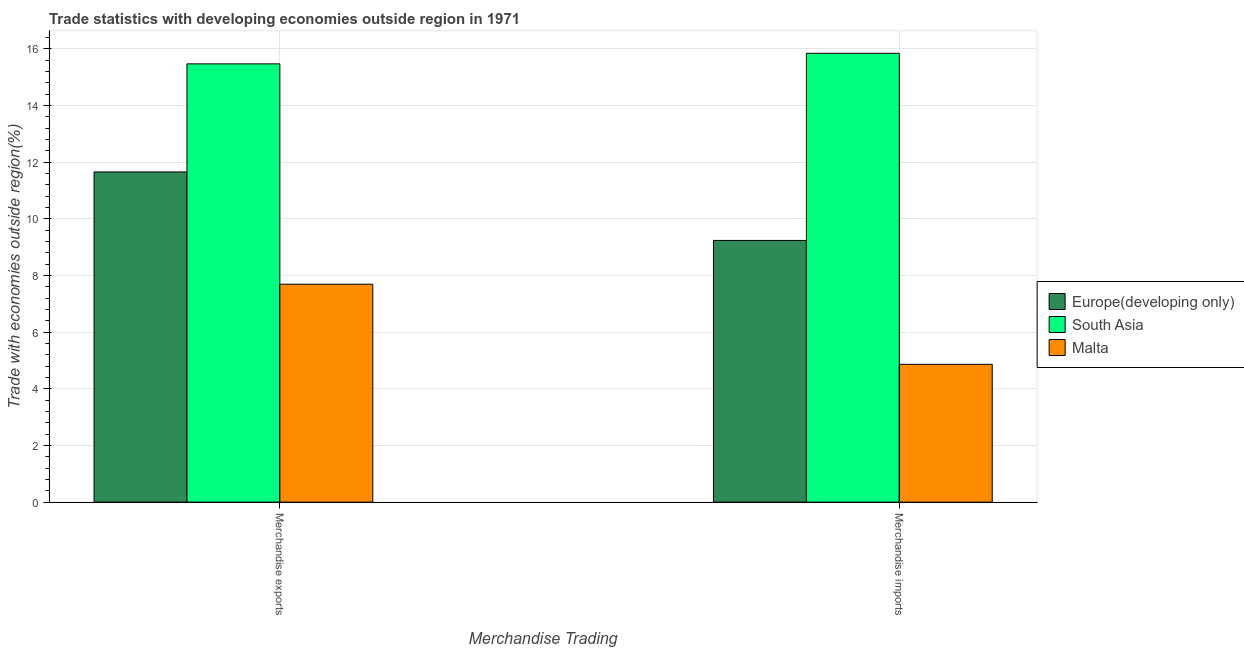How many groups of bars are there?
Your answer should be compact. 2. Are the number of bars per tick equal to the number of legend labels?
Give a very brief answer. Yes. Are the number of bars on each tick of the X-axis equal?
Make the answer very short. Yes. How many bars are there on the 2nd tick from the right?
Your response must be concise. 3. What is the label of the 1st group of bars from the left?
Your response must be concise. Merchandise exports. What is the merchandise exports in Malta?
Your answer should be very brief. 7.69. Across all countries, what is the maximum merchandise exports?
Provide a succinct answer. 15.47. Across all countries, what is the minimum merchandise imports?
Your response must be concise. 4.86. In which country was the merchandise imports minimum?
Ensure brevity in your answer.  Malta. What is the total merchandise exports in the graph?
Ensure brevity in your answer.  34.82. What is the difference between the merchandise imports in Europe(developing only) and that in South Asia?
Ensure brevity in your answer.  -6.61. What is the difference between the merchandise imports in Malta and the merchandise exports in Europe(developing only)?
Offer a very short reply. -6.79. What is the average merchandise imports per country?
Your response must be concise. 9.98. What is the difference between the merchandise imports and merchandise exports in South Asia?
Your response must be concise. 0.37. What is the ratio of the merchandise exports in South Asia to that in Europe(developing only)?
Your answer should be compact. 1.33. In how many countries, is the merchandise exports greater than the average merchandise exports taken over all countries?
Offer a very short reply. 2. What does the 1st bar from the left in Merchandise imports represents?
Offer a very short reply. Europe(developing only). How many bars are there?
Offer a terse response. 6. What is the difference between two consecutive major ticks on the Y-axis?
Your answer should be very brief. 2. Does the graph contain grids?
Offer a very short reply. Yes. Where does the legend appear in the graph?
Provide a short and direct response. Center right. How are the legend labels stacked?
Make the answer very short. Vertical. What is the title of the graph?
Provide a short and direct response. Trade statistics with developing economies outside region in 1971. What is the label or title of the X-axis?
Keep it short and to the point. Merchandise Trading. What is the label or title of the Y-axis?
Offer a very short reply. Trade with economies outside region(%). What is the Trade with economies outside region(%) in Europe(developing only) in Merchandise exports?
Make the answer very short. 11.66. What is the Trade with economies outside region(%) of South Asia in Merchandise exports?
Offer a very short reply. 15.47. What is the Trade with economies outside region(%) in Malta in Merchandise exports?
Your answer should be very brief. 7.69. What is the Trade with economies outside region(%) of Europe(developing only) in Merchandise imports?
Provide a short and direct response. 9.24. What is the Trade with economies outside region(%) of South Asia in Merchandise imports?
Give a very brief answer. 15.84. What is the Trade with economies outside region(%) of Malta in Merchandise imports?
Your response must be concise. 4.86. Across all Merchandise Trading, what is the maximum Trade with economies outside region(%) in Europe(developing only)?
Provide a succinct answer. 11.66. Across all Merchandise Trading, what is the maximum Trade with economies outside region(%) of South Asia?
Make the answer very short. 15.84. Across all Merchandise Trading, what is the maximum Trade with economies outside region(%) of Malta?
Provide a succinct answer. 7.69. Across all Merchandise Trading, what is the minimum Trade with economies outside region(%) of Europe(developing only)?
Your answer should be compact. 9.24. Across all Merchandise Trading, what is the minimum Trade with economies outside region(%) in South Asia?
Make the answer very short. 15.47. Across all Merchandise Trading, what is the minimum Trade with economies outside region(%) of Malta?
Offer a terse response. 4.86. What is the total Trade with economies outside region(%) in Europe(developing only) in the graph?
Give a very brief answer. 20.89. What is the total Trade with economies outside region(%) in South Asia in the graph?
Your answer should be compact. 31.31. What is the total Trade with economies outside region(%) in Malta in the graph?
Keep it short and to the point. 12.56. What is the difference between the Trade with economies outside region(%) of Europe(developing only) in Merchandise exports and that in Merchandise imports?
Your answer should be very brief. 2.42. What is the difference between the Trade with economies outside region(%) in South Asia in Merchandise exports and that in Merchandise imports?
Provide a succinct answer. -0.37. What is the difference between the Trade with economies outside region(%) of Malta in Merchandise exports and that in Merchandise imports?
Your answer should be very brief. 2.83. What is the difference between the Trade with economies outside region(%) in Europe(developing only) in Merchandise exports and the Trade with economies outside region(%) in South Asia in Merchandise imports?
Your response must be concise. -4.19. What is the difference between the Trade with economies outside region(%) in Europe(developing only) in Merchandise exports and the Trade with economies outside region(%) in Malta in Merchandise imports?
Your answer should be compact. 6.79. What is the difference between the Trade with economies outside region(%) in South Asia in Merchandise exports and the Trade with economies outside region(%) in Malta in Merchandise imports?
Ensure brevity in your answer.  10.61. What is the average Trade with economies outside region(%) in Europe(developing only) per Merchandise Trading?
Provide a short and direct response. 10.45. What is the average Trade with economies outside region(%) of South Asia per Merchandise Trading?
Keep it short and to the point. 15.66. What is the average Trade with economies outside region(%) in Malta per Merchandise Trading?
Give a very brief answer. 6.28. What is the difference between the Trade with economies outside region(%) in Europe(developing only) and Trade with economies outside region(%) in South Asia in Merchandise exports?
Keep it short and to the point. -3.81. What is the difference between the Trade with economies outside region(%) of Europe(developing only) and Trade with economies outside region(%) of Malta in Merchandise exports?
Your answer should be very brief. 3.96. What is the difference between the Trade with economies outside region(%) in South Asia and Trade with economies outside region(%) in Malta in Merchandise exports?
Your response must be concise. 7.78. What is the difference between the Trade with economies outside region(%) in Europe(developing only) and Trade with economies outside region(%) in South Asia in Merchandise imports?
Your response must be concise. -6.61. What is the difference between the Trade with economies outside region(%) of Europe(developing only) and Trade with economies outside region(%) of Malta in Merchandise imports?
Give a very brief answer. 4.37. What is the difference between the Trade with economies outside region(%) of South Asia and Trade with economies outside region(%) of Malta in Merchandise imports?
Provide a short and direct response. 10.98. What is the ratio of the Trade with economies outside region(%) in Europe(developing only) in Merchandise exports to that in Merchandise imports?
Offer a terse response. 1.26. What is the ratio of the Trade with economies outside region(%) in South Asia in Merchandise exports to that in Merchandise imports?
Provide a short and direct response. 0.98. What is the ratio of the Trade with economies outside region(%) in Malta in Merchandise exports to that in Merchandise imports?
Offer a very short reply. 1.58. What is the difference between the highest and the second highest Trade with economies outside region(%) in Europe(developing only)?
Keep it short and to the point. 2.42. What is the difference between the highest and the second highest Trade with economies outside region(%) of South Asia?
Give a very brief answer. 0.37. What is the difference between the highest and the second highest Trade with economies outside region(%) of Malta?
Ensure brevity in your answer.  2.83. What is the difference between the highest and the lowest Trade with economies outside region(%) of Europe(developing only)?
Make the answer very short. 2.42. What is the difference between the highest and the lowest Trade with economies outside region(%) in South Asia?
Your answer should be very brief. 0.37. What is the difference between the highest and the lowest Trade with economies outside region(%) in Malta?
Offer a very short reply. 2.83. 